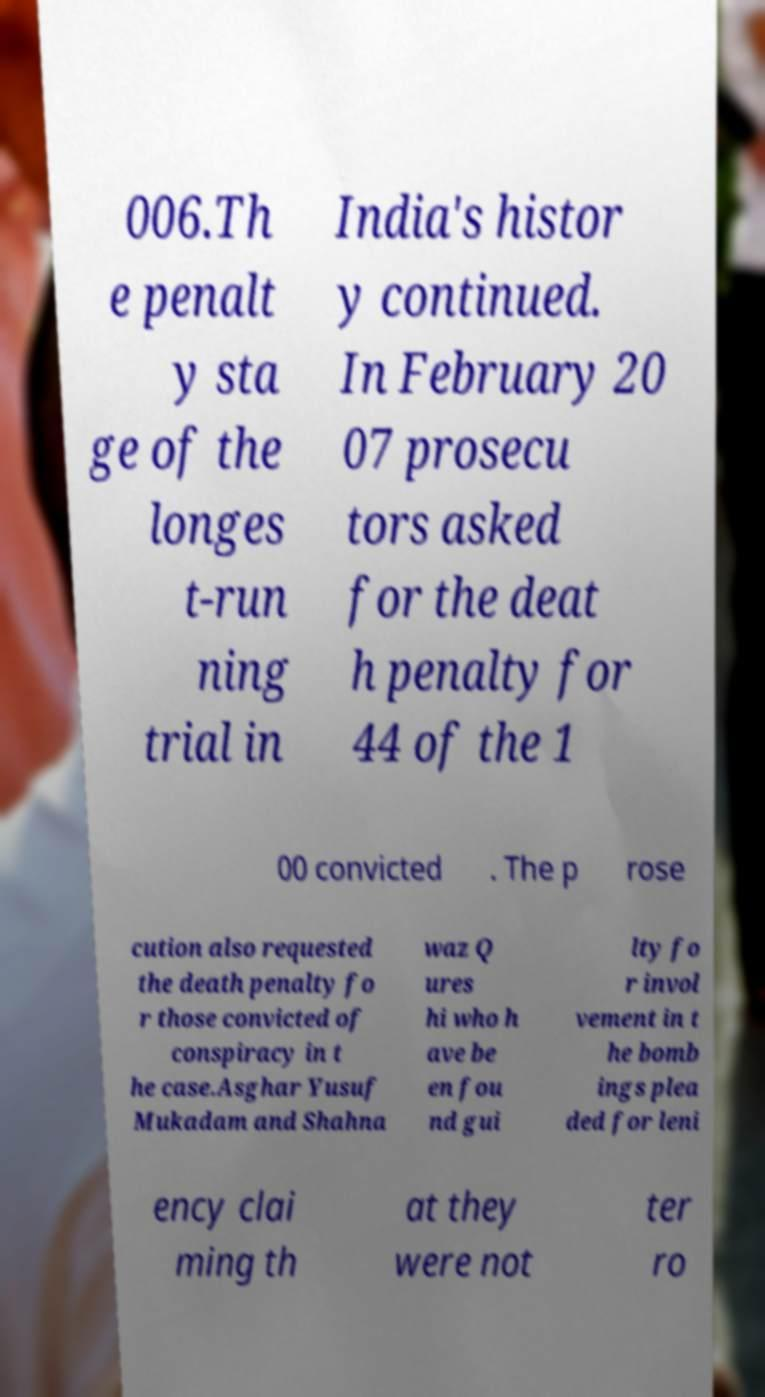Could you assist in decoding the text presented in this image and type it out clearly? 006.Th e penalt y sta ge of the longes t-run ning trial in India's histor y continued. In February 20 07 prosecu tors asked for the deat h penalty for 44 of the 1 00 convicted . The p rose cution also requested the death penalty fo r those convicted of conspiracy in t he case.Asghar Yusuf Mukadam and Shahna waz Q ures hi who h ave be en fou nd gui lty fo r invol vement in t he bomb ings plea ded for leni ency clai ming th at they were not ter ro 